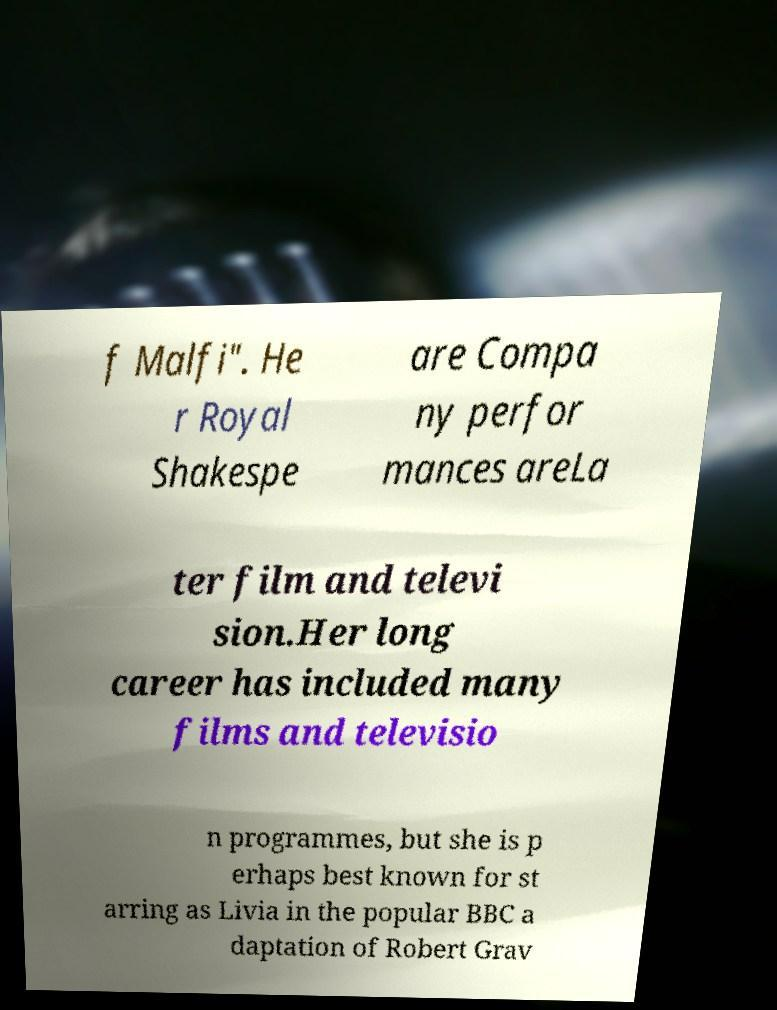Could you extract and type out the text from this image? f Malfi". He r Royal Shakespe are Compa ny perfor mances areLa ter film and televi sion.Her long career has included many films and televisio n programmes, but she is p erhaps best known for st arring as Livia in the popular BBC a daptation of Robert Grav 